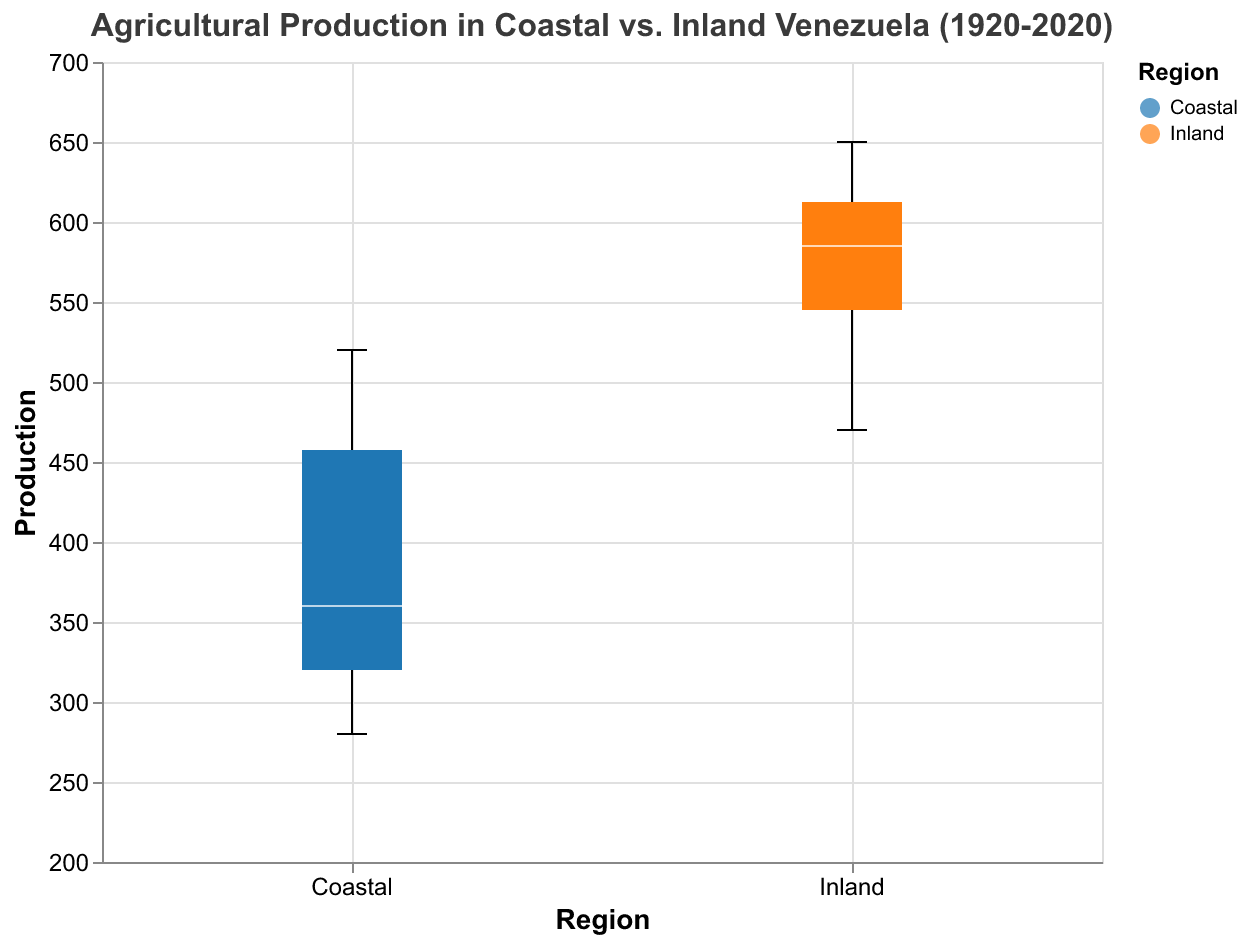What is the title of the figure? The title of the figure is displayed at the top. It reads, "Agricultural Production in Coastal vs. Inland Venezuela (1920-2020)."
Answer: Agricultural Production in Coastal vs. Inland Venezuela (1920-2020) How many data points fall within the production range of 200 to 400 in the Coastal region? By looking closely at the Coastal box plots for different years, you count the data points that fall within the production range of 200 to 400.
Answer: 6 Which region shows a higher median production? You can observe the position of the median lines within the boxplot for both regions. Inland region's median is higher than the Coastal region's across the years.
Answer: Inland What is the similarity in production between Coastal Coffee in 2020 and Inland Wheat in 1960? Look at the height of the box plots for Coastal Coffee (2020) and Inland Wheat (1960) and observe their production values. Both Coastal Coffee in 2020 and Inland Wheat in 1960 have production values around 520 and 610 respectively.
Answer: Similarity: Both are increasing but are at different absolute values Which region exhibits more variability in agricultural production? Variability in a box plot is indicated by the length of the box (IQR) and the presence/position of outliers. Inland has a larger range of production values, indicating more variability.
Answer: Inland What is the difference in production between Coastal Cocoa in 1920 and Inland Rice in 2020? Find the production value for Coastal Cocoa in 1920 (320) and Inland Rice in 2020 (620). Calculate the difference: 620 - 320 = 300.
Answer: 300 Compare the production trend of Coffee in the Coastal region from 1920 to 2020 with that of Rice in the Inland region over the same period. Observe the box plots for Coffee in the Coastal region and Rice in the Inland region from 1920 to 2020. Coffee in the Coastal region and Rice in the Inland region both show an increasing trend in production over time.
Answer: Both show increasing trends Is the production of Corn in the Coastal region in 2020 higher than the production of Sorghum in the Inland region in 1920? Locate the production values for Corn in the Coastal region in 2020 (350) and Sorghum in the Inland region in 1920 (470). Compare the two values. Corn in Coastal region in 2020 is lower than Sorghum in Inland region in 1920.
Answer: No Which crop in the Coastal region had the smallest increase in production from 1920 to 2020? For each crop in the Coastal region, calculate the difference between the production values in 1920 and 2020. Corn had an increase from 280 to 350, which is 70. Cocoa increased from 320 to 390, which is 70. Coffee increased from 450 to 520, which is 70. All crops in Coastal region had the same increase of 70.
Answer: Corn/Cocoa/Coffee (all had the same increase) Between Coastal Coffee and Coastal Corn, which showed a higher production increase from 1960 to 2020? Look at Coffee and Corn productions in the Coastal region for 1960 and 2020. For Coffee, the increase is 520 - 480 = 40. For Corn, the increase is 350 - 300 = 50. Corn showed a higher increase.
Answer: Corn 